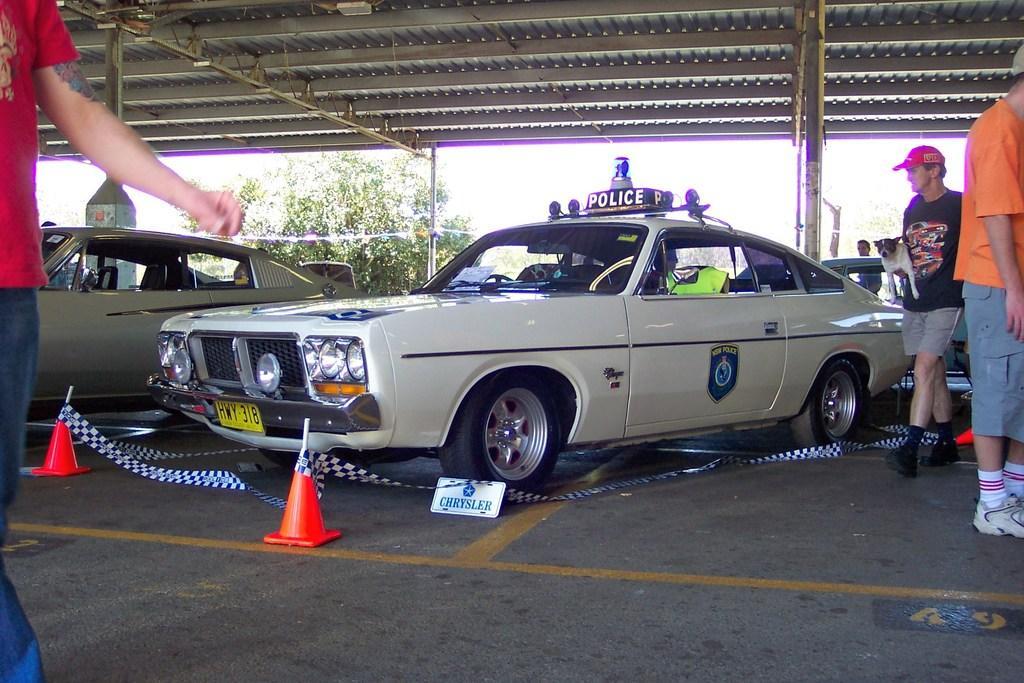Please provide a concise description of this image. In the center of the image we can see the cars are present. At the top of the image roof is there. In the middle of the image a plant is there. At the bottom of the image we can see divider cone, board, floor are present. On the left and right side of the image two persons are standing. On the left side of the image a man is walking and holding a dog and wearing a cap. 